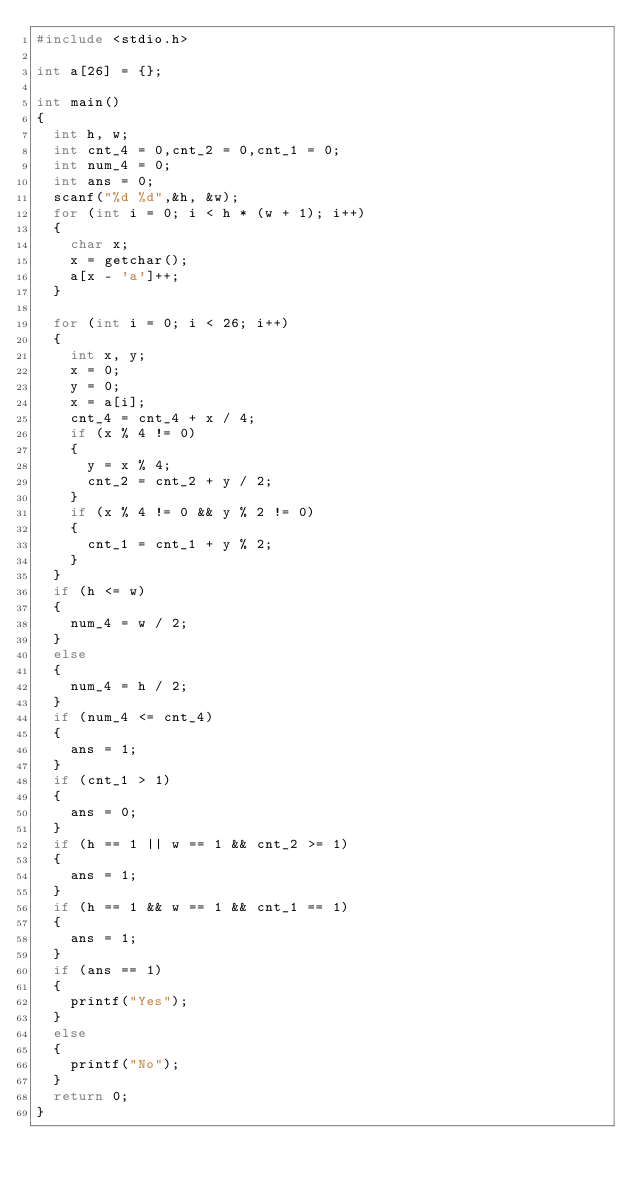<code> <loc_0><loc_0><loc_500><loc_500><_C_>#include <stdio.h>

int a[26] = {};

int main()
{
	int h, w;
	int cnt_4 = 0,cnt_2 = 0,cnt_1 = 0;
	int num_4 = 0;
	int ans = 0;
	scanf("%d %d",&h, &w);
	for (int i = 0; i < h * (w + 1); i++)
	{
		char x;
		x = getchar();
		a[x - 'a']++;
	}

	for (int i = 0; i < 26; i++)
	{
		int x, y;
		x = 0;
		y = 0;
		x = a[i];
		cnt_4 = cnt_4 + x / 4;
		if (x % 4 != 0)
		{
			y = x % 4;
			cnt_2 = cnt_2 + y / 2;
		}
		if (x % 4 != 0 && y % 2 != 0)
		{
			cnt_1 = cnt_1 + y % 2;
		}
	}
	if (h <= w)
	{
		num_4 = w / 2;
	}
	else
	{
		num_4 = h / 2;
	}
	if (num_4 <= cnt_4)
	{
		ans = 1;
	}
	if (cnt_1 > 1)
	{
		ans = 0;
	}
	if (h == 1 || w == 1 && cnt_2 >= 1)
	{
		ans = 1;
	}
	if (h == 1 && w == 1 && cnt_1 == 1)
	{
		ans = 1;
	}
	if (ans == 1)
	{
		printf("Yes");
	}
	else
	{
		printf("No");
	}
	return 0;
}</code> 